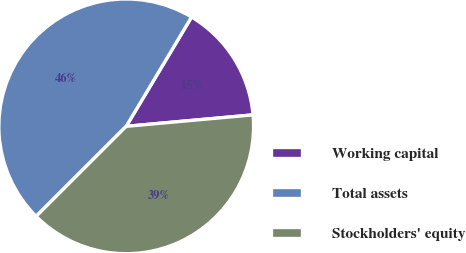Convert chart. <chart><loc_0><loc_0><loc_500><loc_500><pie_chart><fcel>Working capital<fcel>Total assets<fcel>Stockholders' equity<nl><fcel>14.99%<fcel>46.07%<fcel>38.94%<nl></chart> 